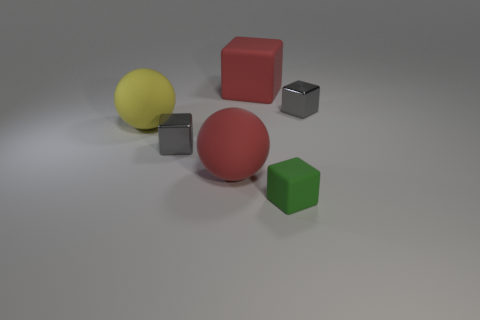What shape is the large thing that is the same color as the big matte block?
Your answer should be compact. Sphere. There is a matte thing that is in front of the large cube and on the right side of the red ball; how big is it?
Offer a terse response. Small. What number of green rubber blocks are there?
Offer a terse response. 1. What number of balls are either green things or tiny green metallic things?
Your response must be concise. 0. How many gray shiny things are behind the metallic object on the right side of the small gray cube on the left side of the red cube?
Provide a short and direct response. 0. The other matte ball that is the same size as the yellow ball is what color?
Provide a short and direct response. Red. What number of other things are the same color as the small rubber thing?
Provide a succinct answer. 0. Are there more large things right of the small green matte block than small gray things?
Provide a short and direct response. No. Are the big yellow sphere and the red sphere made of the same material?
Keep it short and to the point. Yes. How many objects are gray shiny blocks behind the big yellow ball or rubber blocks?
Offer a terse response. 3. 